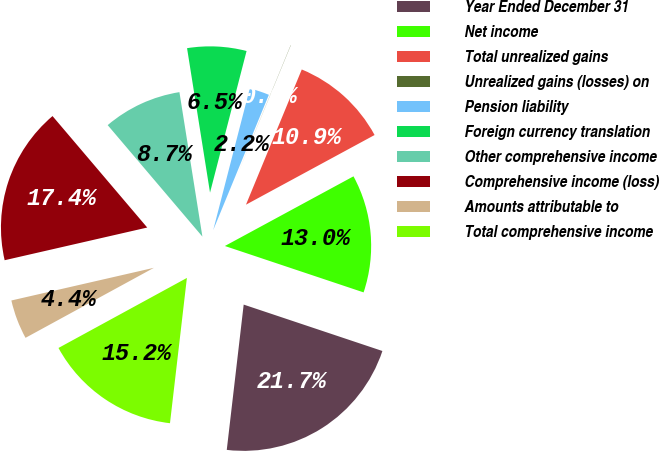<chart> <loc_0><loc_0><loc_500><loc_500><pie_chart><fcel>Year Ended December 31<fcel>Net income<fcel>Total unrealized gains<fcel>Unrealized gains (losses) on<fcel>Pension liability<fcel>Foreign currency translation<fcel>Other comprehensive income<fcel>Comprehensive income (loss)<fcel>Amounts attributable to<fcel>Total comprehensive income<nl><fcel>21.71%<fcel>13.04%<fcel>10.87%<fcel>0.02%<fcel>2.19%<fcel>6.53%<fcel>8.7%<fcel>17.38%<fcel>4.36%<fcel>15.21%<nl></chart> 